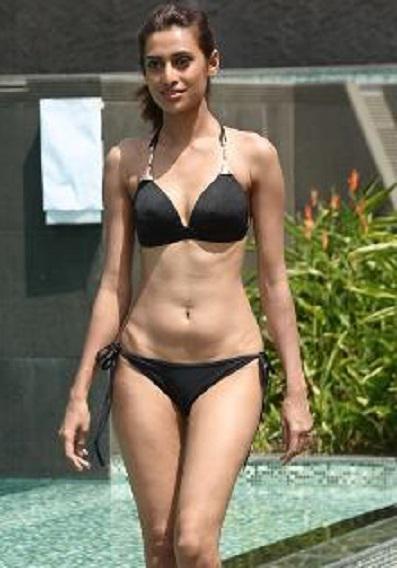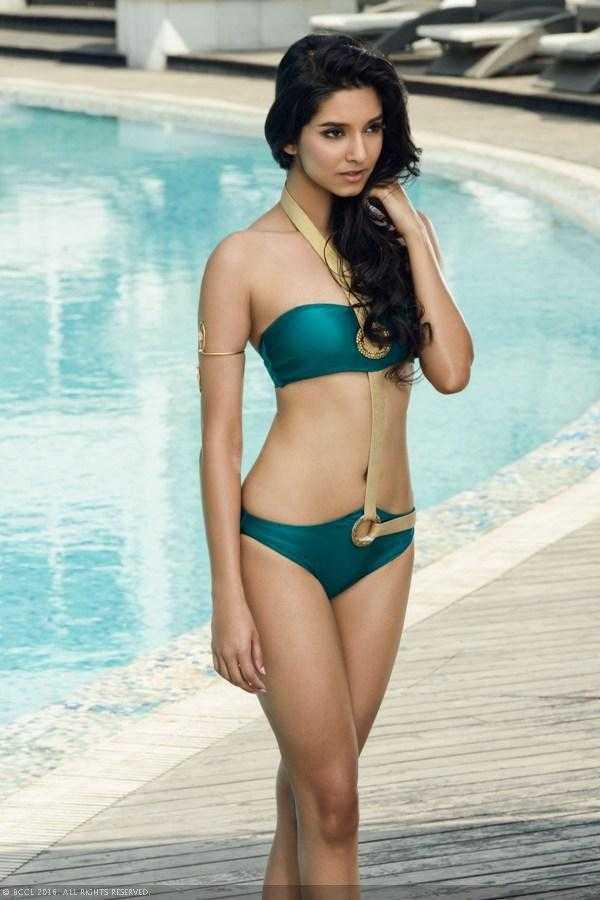The first image is the image on the left, the second image is the image on the right. Examine the images to the left and right. Is the description "An image shows a standing model in a teal bikini with her long black hair swept to the right side and her gaze aimed rightward." accurate? Answer yes or no. Yes. The first image is the image on the left, the second image is the image on the right. Assess this claim about the two images: "A woman is touching her hair.". Correct or not? Answer yes or no. Yes. 